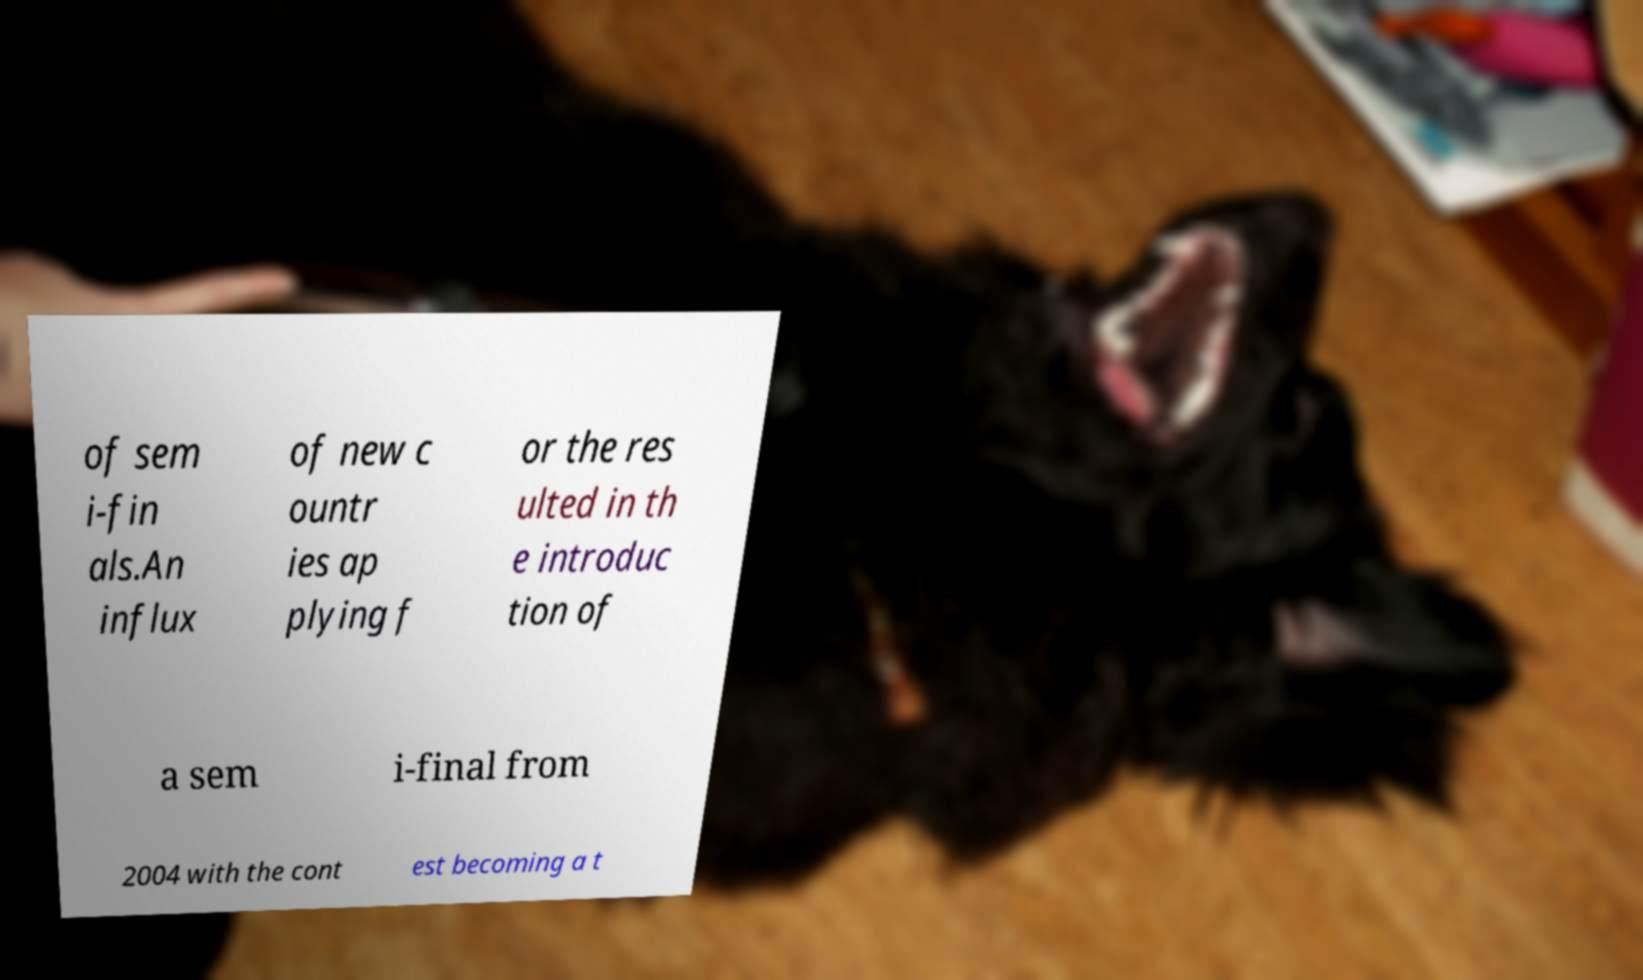There's text embedded in this image that I need extracted. Can you transcribe it verbatim? of sem i-fin als.An influx of new c ountr ies ap plying f or the res ulted in th e introduc tion of a sem i-final from 2004 with the cont est becoming a t 